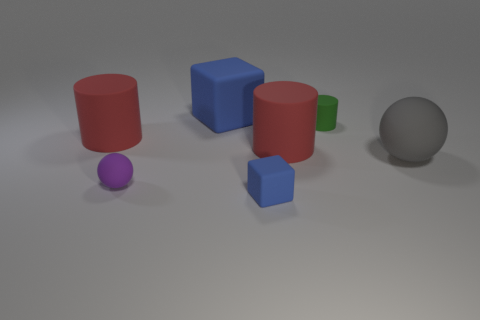Subtract all red matte cylinders. How many cylinders are left? 1 Add 2 big purple rubber balls. How many objects exist? 9 Add 5 gray matte spheres. How many gray matte spheres exist? 6 Subtract all purple spheres. How many spheres are left? 1 Subtract 0 yellow cylinders. How many objects are left? 7 Subtract all spheres. How many objects are left? 5 Subtract 1 balls. How many balls are left? 1 Subtract all cyan cylinders. Subtract all brown balls. How many cylinders are left? 3 Subtract all red balls. How many yellow cylinders are left? 0 Subtract all rubber things. Subtract all purple cylinders. How many objects are left? 0 